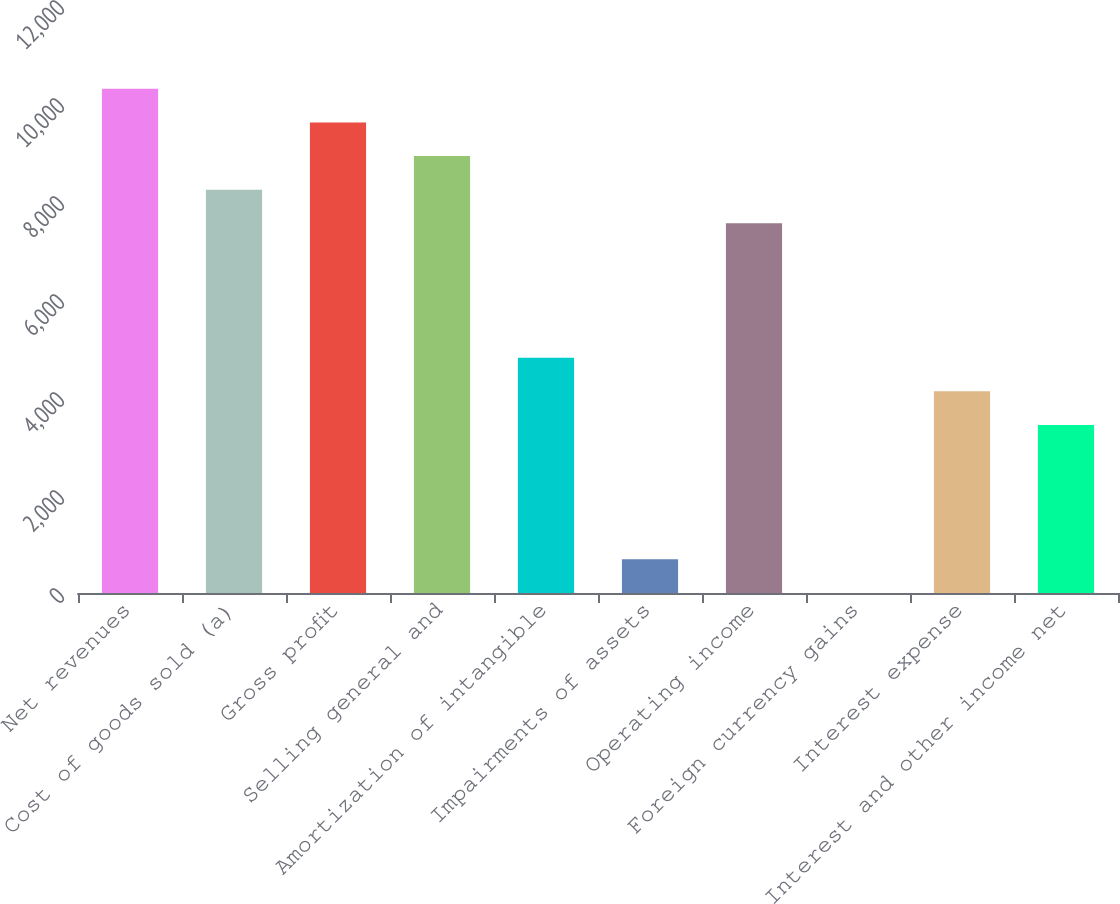Convert chart to OTSL. <chart><loc_0><loc_0><loc_500><loc_500><bar_chart><fcel>Net revenues<fcel>Cost of goods sold (a)<fcel>Gross profit<fcel>Selling general and<fcel>Amortization of intangible<fcel>Impairments of assets<fcel>Operating income<fcel>Foreign currency gains<fcel>Interest expense<fcel>Interest and other income net<nl><fcel>10288.5<fcel>8231.1<fcel>9602.7<fcel>8916.9<fcel>4802.1<fcel>687.3<fcel>7545.3<fcel>1.5<fcel>4116.3<fcel>3430.5<nl></chart> 